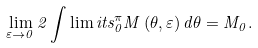Convert formula to latex. <formula><loc_0><loc_0><loc_500><loc_500>\lim _ { \varepsilon \rightarrow 0 } 2 \int \lim i t s _ { 0 } ^ { \pi } M \left ( \theta , \varepsilon \right ) d \theta = M _ { 0 } .</formula> 